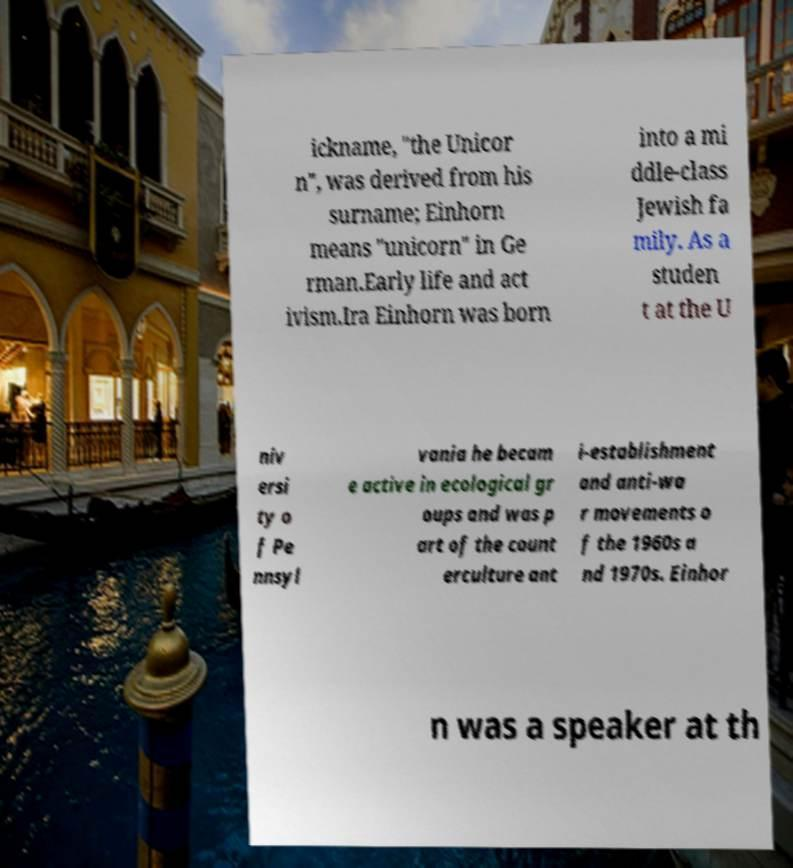Please read and relay the text visible in this image. What does it say? ickname, "the Unicor n", was derived from his surname; Einhorn means "unicorn" in Ge rman.Early life and act ivism.Ira Einhorn was born into a mi ddle-class Jewish fa mily. As a studen t at the U niv ersi ty o f Pe nnsyl vania he becam e active in ecological gr oups and was p art of the count erculture ant i-establishment and anti-wa r movements o f the 1960s a nd 1970s. Einhor n was a speaker at th 